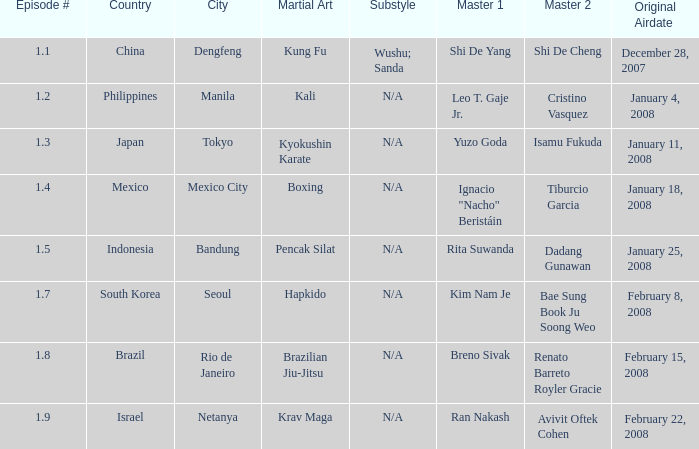Which masters fought in hapkido style? Kim Nam Je, Bae Sung Book Ju Soong Weo. 